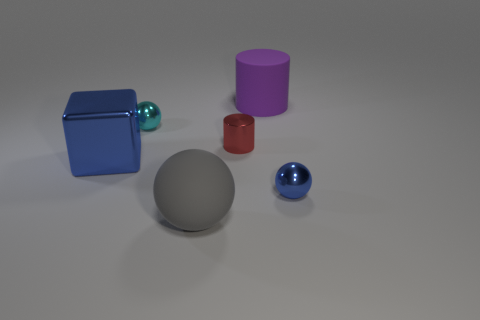There is a tiny metallic object that is the same color as the large metallic thing; what is its shape?
Offer a terse response. Sphere. There is a metallic object on the right side of the red shiny thing; is its color the same as the big block?
Provide a succinct answer. Yes. There is a blue metallic object that is to the left of the gray sphere; is it the same shape as the large thing behind the red cylinder?
Offer a very short reply. No. Are there any other things that have the same shape as the big gray rubber thing?
Offer a very short reply. Yes. There is a tiny cyan thing that is made of the same material as the tiny red cylinder; what shape is it?
Your answer should be compact. Sphere. Is the number of matte things on the left side of the tiny red object the same as the number of yellow rubber blocks?
Offer a very short reply. No. Is the material of the large object that is in front of the small blue metallic ball the same as the object that is left of the cyan shiny object?
Your answer should be compact. No. What shape is the rubber thing that is in front of the large object to the right of the tiny red cylinder?
Your answer should be compact. Sphere. What is the color of the large ball that is made of the same material as the large purple cylinder?
Ensure brevity in your answer.  Gray. Is the large matte cylinder the same color as the large shiny object?
Provide a short and direct response. No. 